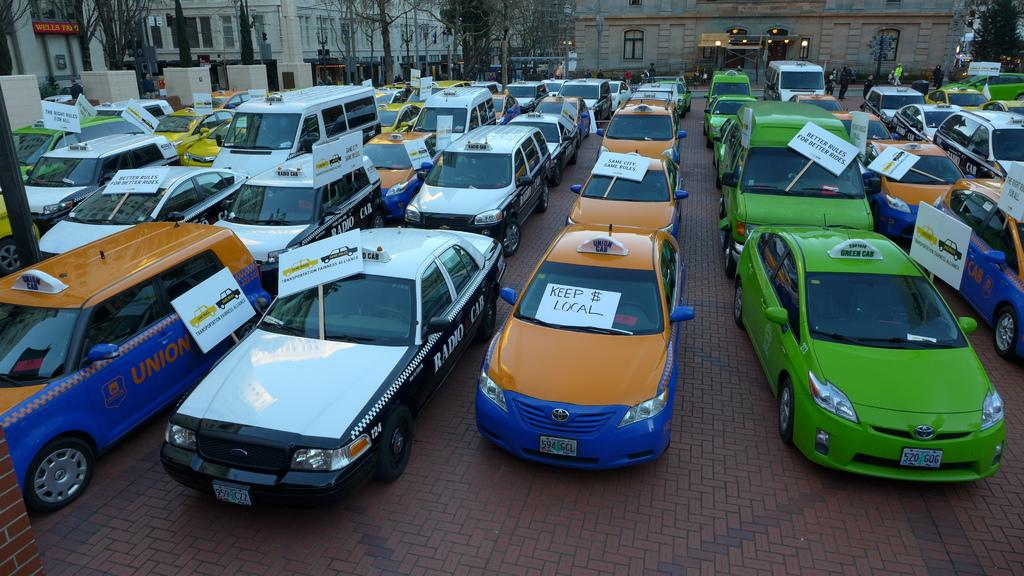<image>
Write a terse but informative summary of the picture. Vehicles parked on a parking lot with one that says "Keep $ Local". 